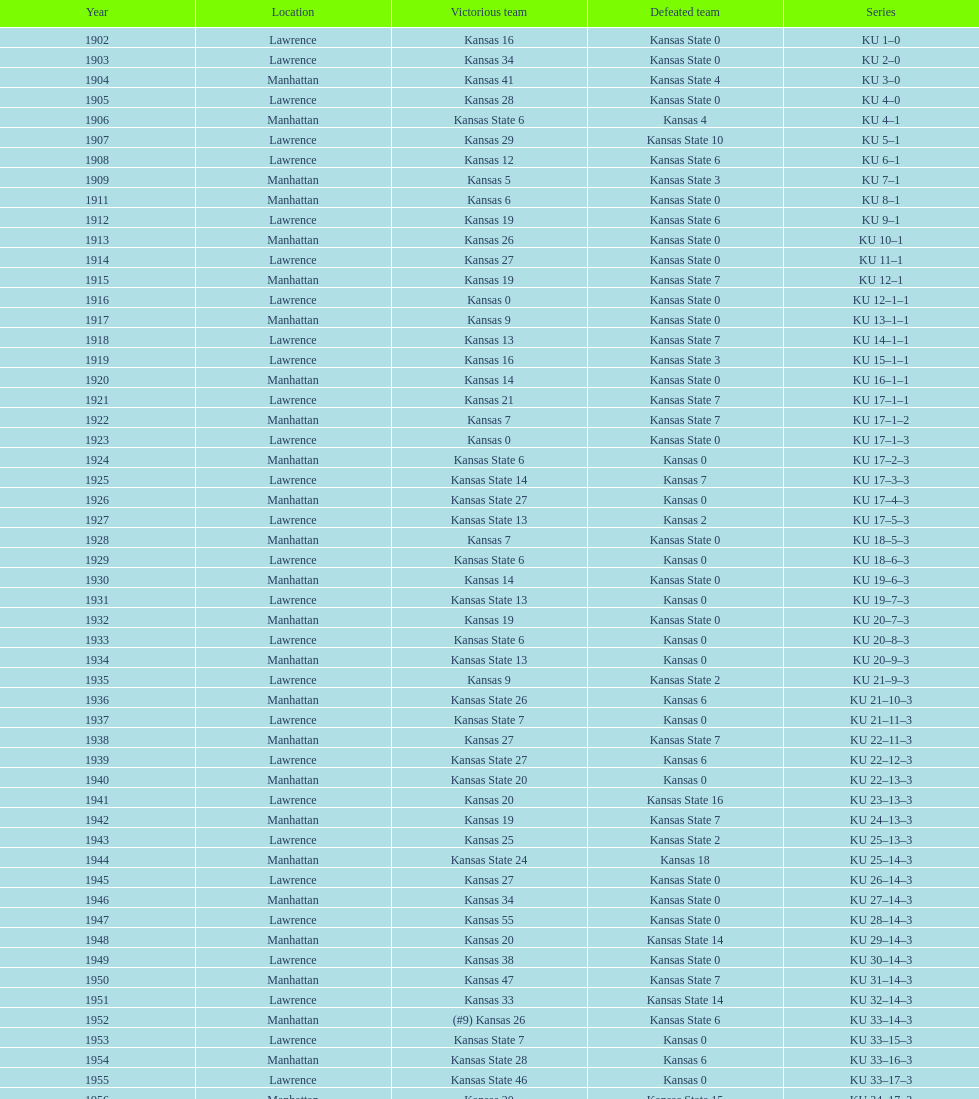How many times did kansas beat kansas state before 1910? 7. 